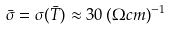Convert formula to latex. <formula><loc_0><loc_0><loc_500><loc_500>\bar { \sigma } = \sigma ( \bar { T } ) \approx 3 0 \, ( \Omega c m ) ^ { - 1 }</formula> 